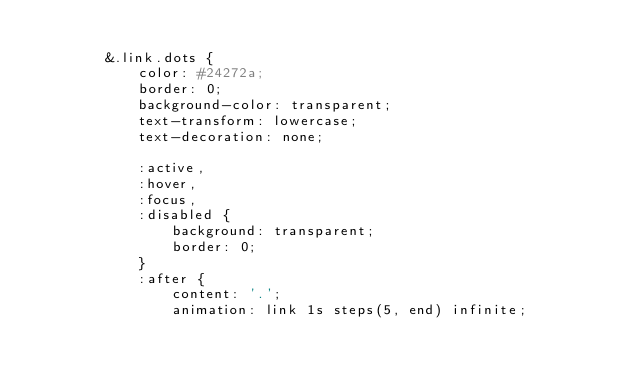Convert code to text. <code><loc_0><loc_0><loc_500><loc_500><_JavaScript_>
        &.link.dots {
            color: #24272a;
            border: 0;
            background-color: transparent;
            text-transform: lowercase;
            text-decoration: none;

            :active,
            :hover,
            :focus,
            :disabled {
                background: transparent;
                border: 0;
            }
            :after {
                content: '.';
                animation: link 1s steps(5, end) infinite;
            </code> 